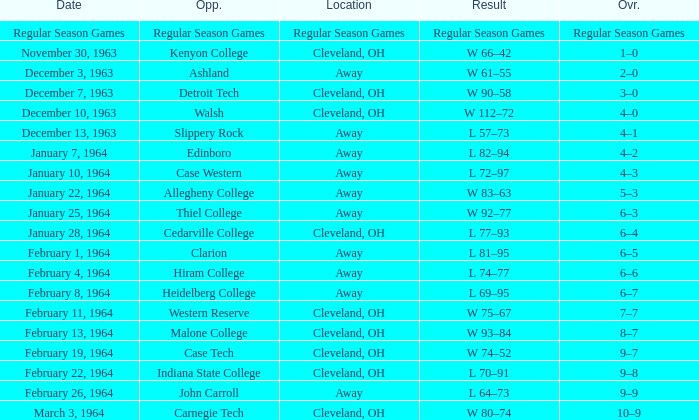Parse the full table. {'header': ['Date', 'Opp.', 'Location', 'Result', 'Ovr.'], 'rows': [['Regular Season Games', 'Regular Season Games', 'Regular Season Games', 'Regular Season Games', 'Regular Season Games'], ['November 30, 1963', 'Kenyon College', 'Cleveland, OH', 'W 66–42', '1–0'], ['December 3, 1963', 'Ashland', 'Away', 'W 61–55', '2–0'], ['December 7, 1963', 'Detroit Tech', 'Cleveland, OH', 'W 90–58', '3–0'], ['December 10, 1963', 'Walsh', 'Cleveland, OH', 'W 112–72', '4–0'], ['December 13, 1963', 'Slippery Rock', 'Away', 'L 57–73', '4–1'], ['January 7, 1964', 'Edinboro', 'Away', 'L 82–94', '4–2'], ['January 10, 1964', 'Case Western', 'Away', 'L 72–97', '4–3'], ['January 22, 1964', 'Allegheny College', 'Away', 'W 83–63', '5–3'], ['January 25, 1964', 'Thiel College', 'Away', 'W 92–77', '6–3'], ['January 28, 1964', 'Cedarville College', 'Cleveland, OH', 'L 77–93', '6–4'], ['February 1, 1964', 'Clarion', 'Away', 'L 81–95', '6–5'], ['February 4, 1964', 'Hiram College', 'Away', 'L 74–77', '6–6'], ['February 8, 1964', 'Heidelberg College', 'Away', 'L 69–95', '6–7'], ['February 11, 1964', 'Western Reserve', 'Cleveland, OH', 'W 75–67', '7–7'], ['February 13, 1964', 'Malone College', 'Cleveland, OH', 'W 93–84', '8–7'], ['February 19, 1964', 'Case Tech', 'Cleveland, OH', 'W 74–52', '9–7'], ['February 22, 1964', 'Indiana State College', 'Cleveland, OH', 'L 70–91', '9–8'], ['February 26, 1964', 'John Carroll', 'Away', 'L 64–73', '9–9'], ['March 3, 1964', 'Carnegie Tech', 'Cleveland, OH', 'W 80–74', '10–9']]} What is the Location with a Date that is december 10, 1963? Cleveland, OH. 